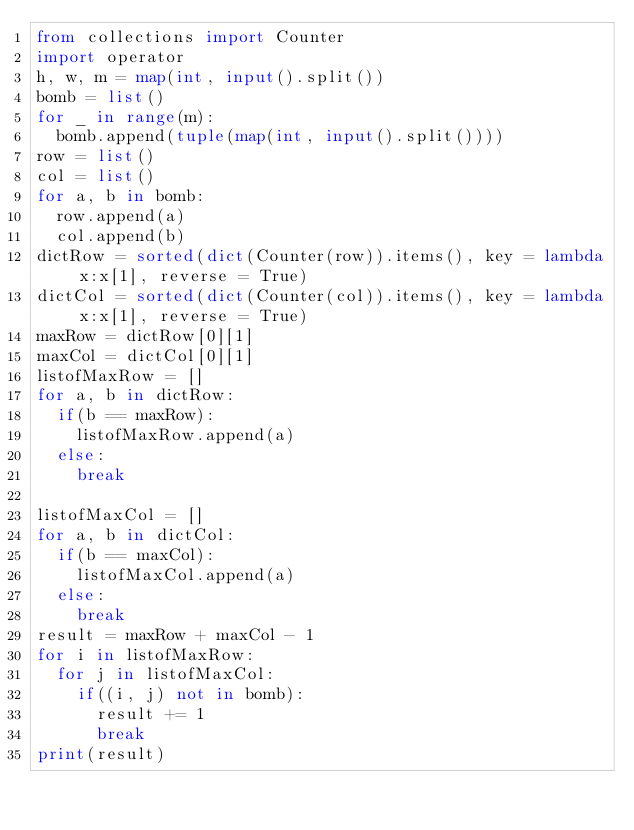<code> <loc_0><loc_0><loc_500><loc_500><_Python_>from collections import Counter
import operator
h, w, m = map(int, input().split())
bomb = list()
for _ in range(m):
  bomb.append(tuple(map(int, input().split())))
row = list()
col = list()
for a, b in bomb:
  row.append(a)
  col.append(b) 
dictRow = sorted(dict(Counter(row)).items(), key = lambda x:x[1], reverse = True)
dictCol = sorted(dict(Counter(col)).items(), key = lambda x:x[1], reverse = True)
maxRow = dictRow[0][1]
maxCol = dictCol[0][1]
listofMaxRow = []
for a, b in dictRow:
  if(b == maxRow):
    listofMaxRow.append(a)
  else:
    break

listofMaxCol = []
for a, b in dictCol: 
  if(b == maxCol):
    listofMaxCol.append(a)
  else:
    break
result = maxRow + maxCol - 1
for i in listofMaxRow:
  for j in listofMaxCol:
    if((i, j) not in bomb):
      result += 1
      break
print(result)



</code> 